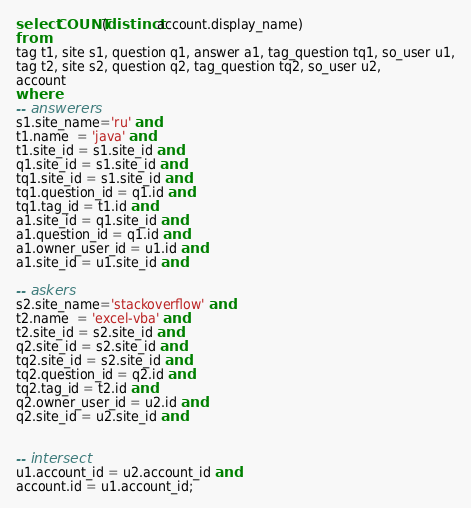<code> <loc_0><loc_0><loc_500><loc_500><_SQL_>
select COUNT(distinct account.display_name)
from
tag t1, site s1, question q1, answer a1, tag_question tq1, so_user u1,
tag t2, site s2, question q2, tag_question tq2, so_user u2,
account
where
-- answerers
s1.site_name='ru' and
t1.name  = 'java' and
t1.site_id = s1.site_id and
q1.site_id = s1.site_id and
tq1.site_id = s1.site_id and
tq1.question_id = q1.id and
tq1.tag_id = t1.id and
a1.site_id = q1.site_id and
a1.question_id = q1.id and
a1.owner_user_id = u1.id and
a1.site_id = u1.site_id and

-- askers
s2.site_name='stackoverflow' and
t2.name  = 'excel-vba' and
t2.site_id = s2.site_id and
q2.site_id = s2.site_id and
tq2.site_id = s2.site_id and
tq2.question_id = q2.id and
tq2.tag_id = t2.id and
q2.owner_user_id = u2.id and
q2.site_id = u2.site_id and


-- intersect
u1.account_id = u2.account_id and
account.id = u1.account_id;

</code> 